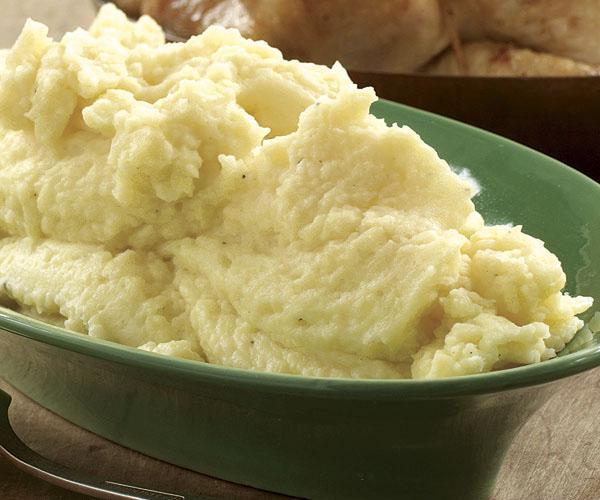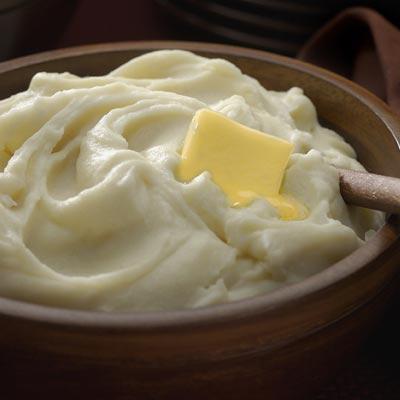The first image is the image on the left, the second image is the image on the right. Analyze the images presented: Is the assertion "A spoon is visible next to one of the dishes of food." valid? Answer yes or no. No. 